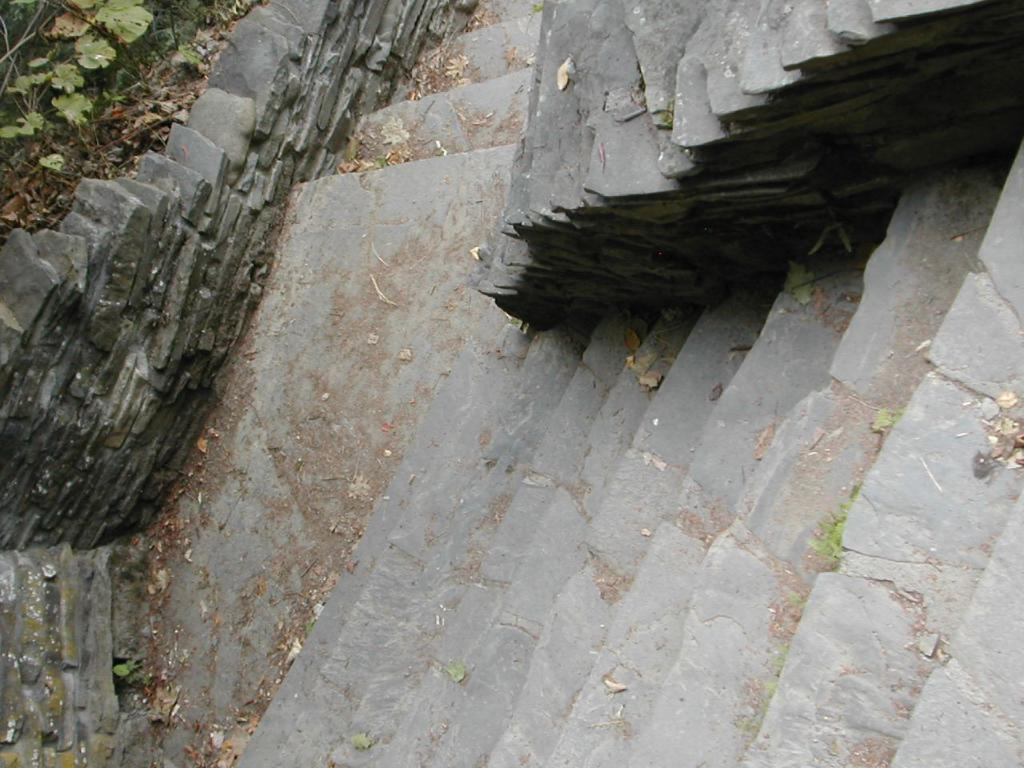What can be seen in the image that people might use to move between different levels? There are steps in the image that people might use to move between different levels. What is the steps going over in the image? The steps are over a place, which could be a path or an area. What type of vegetation is visible on the left top side of the image? There are plants on the left top side of the image. What is present on the ground in the image that indicates a natural process? Dry leaves are present on the ground in the image, which indicates a natural process of leaves falling from trees. How is the cannon being sorted in the image? There is no cannon present in the image, so it cannot be sorted or distributed. 